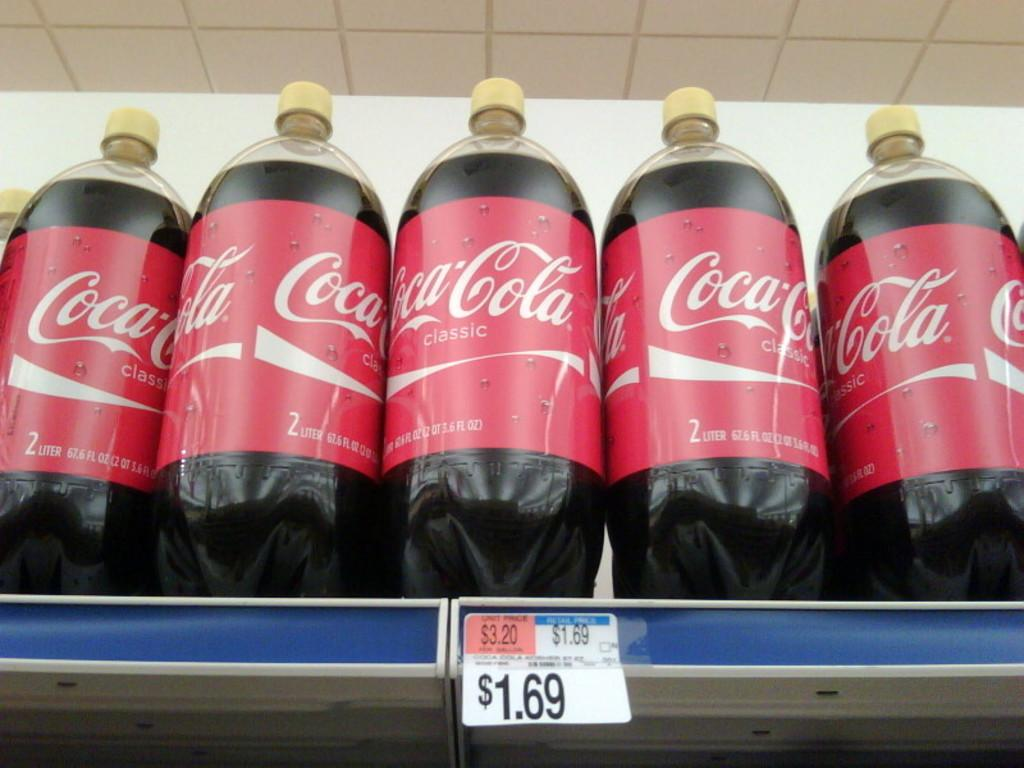How many beverage bottles are visible in the image? There are five beverage bottles in the image. Where are the bottles located in the image? The bottles are arranged on a shelf. What type of pocket is visible on the shelf in the image? There is no pocket visible on the shelf in the image. 